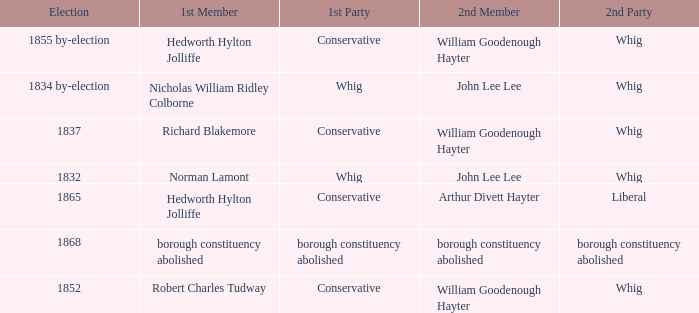What election has a 1st member of richard blakemore and a 2nd member of william goodenough hayter? 1837.0. 